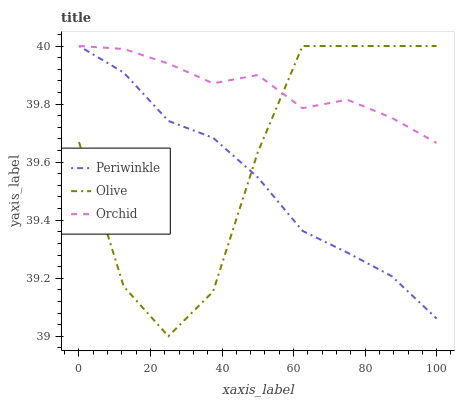Does Periwinkle have the minimum area under the curve?
Answer yes or no. Yes. Does Orchid have the maximum area under the curve?
Answer yes or no. Yes. Does Orchid have the minimum area under the curve?
Answer yes or no. No. Does Periwinkle have the maximum area under the curve?
Answer yes or no. No. Is Periwinkle the smoothest?
Answer yes or no. Yes. Is Olive the roughest?
Answer yes or no. Yes. Is Orchid the smoothest?
Answer yes or no. No. Is Orchid the roughest?
Answer yes or no. No. Does Olive have the lowest value?
Answer yes or no. Yes. Does Periwinkle have the lowest value?
Answer yes or no. No. Does Orchid have the highest value?
Answer yes or no. Yes. Does Periwinkle intersect Olive?
Answer yes or no. Yes. Is Periwinkle less than Olive?
Answer yes or no. No. Is Periwinkle greater than Olive?
Answer yes or no. No. 